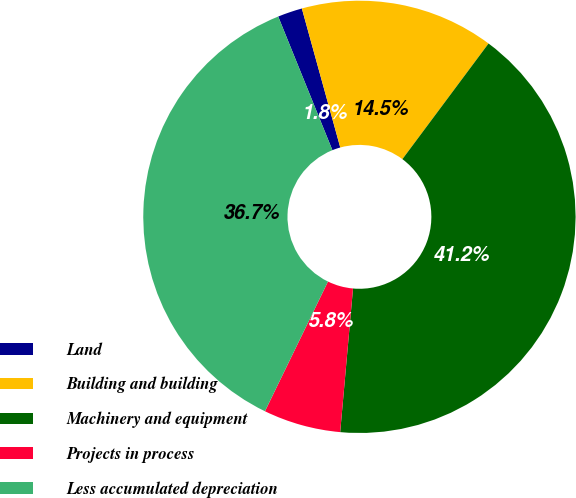Convert chart. <chart><loc_0><loc_0><loc_500><loc_500><pie_chart><fcel>Land<fcel>Building and building<fcel>Machinery and equipment<fcel>Projects in process<fcel>Less accumulated depreciation<nl><fcel>1.84%<fcel>14.48%<fcel>41.23%<fcel>5.78%<fcel>36.67%<nl></chart> 